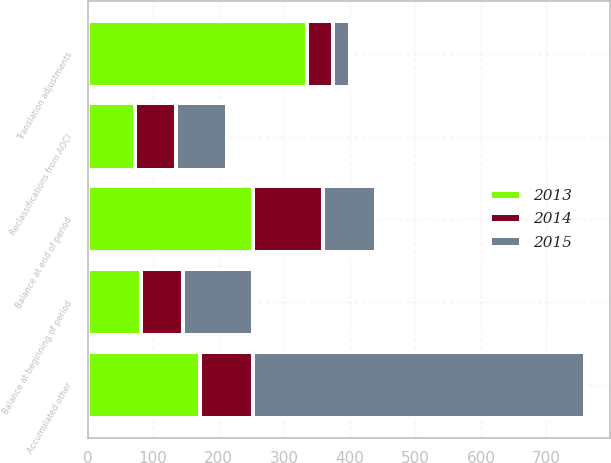Convert chart. <chart><loc_0><loc_0><loc_500><loc_500><stacked_bar_chart><ecel><fcel>Balance at beginning of period<fcel>Translation adjustments<fcel>Balance at end of period<fcel>Reclassifications from AOCI<fcel>Accumulated other<nl><fcel>2013<fcel>81<fcel>334<fcel>253<fcel>72<fcel>172<nl><fcel>2015<fcel>106<fcel>25<fcel>81<fcel>77<fcel>506<nl><fcel>2014<fcel>65<fcel>41<fcel>106<fcel>63<fcel>81<nl></chart> 